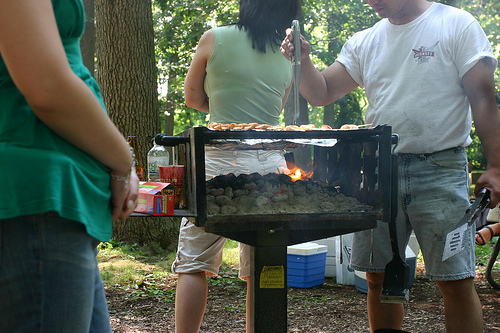<image>
Is the woman behind the grill? Yes. From this viewpoint, the woman is positioned behind the grill, with the grill partially or fully occluding the woman. 